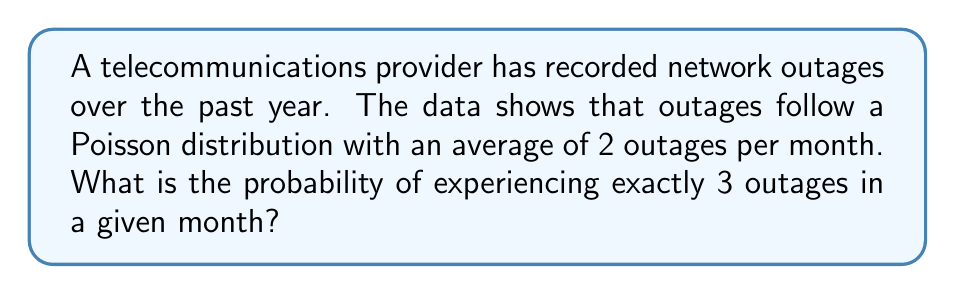Provide a solution to this math problem. To solve this problem, we'll use the Poisson probability mass function:

$$P(X = k) = \frac{e^{-\lambda} \lambda^k}{k!}$$

Where:
$\lambda$ = average number of events in the interval
$k$ = number of events we're calculating the probability for
$e$ = Euler's number (approximately 2.71828)

Given:
$\lambda = 2$ (average of 2 outages per month)
$k = 3$ (we're calculating the probability of exactly 3 outages)

Step 1: Substitute the values into the formula:
$$P(X = 3) = \frac{e^{-2} 2^3}{3!}$$

Step 2: Calculate $2^3$:
$$P(X = 3) = \frac{e^{-2} \cdot 8}{3!}$$

Step 3: Calculate 3! (3 factorial):
$$P(X = 3) = \frac{e^{-2} \cdot 8}{6}$$

Step 4: Simplify:
$$P(X = 3) = \frac{4e^{-2}}{3}$$

Step 5: Calculate $e^{-2}$ (you can use a calculator for this):
$$e^{-2} \approx 0.1353$$

Step 6: Substitute this value and calculate the final result:
$$P(X = 3) = \frac{4 \cdot 0.1353}{3} \approx 0.1804$$

Therefore, the probability of experiencing exactly 3 outages in a given month is approximately 0.1804 or 18.04%.
Answer: 0.1804 